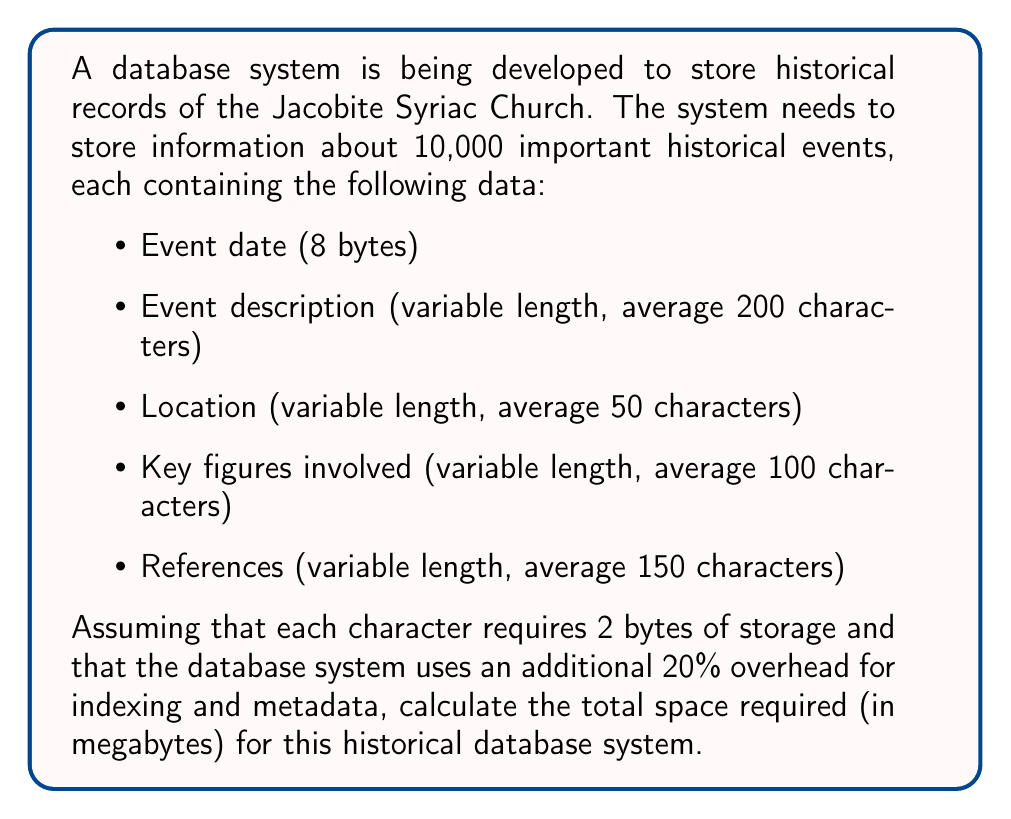Solve this math problem. Let's break down the problem and solve it step by step:

1. Calculate the space required for each field:
   - Event date: 8 bytes
   - Event description: $200 \times 2 = 400$ bytes
   - Location: $50 \times 2 = 100$ bytes
   - Key figures: $100 \times 2 = 200$ bytes
   - References: $150 \times 2 = 300$ bytes

2. Calculate the total space for one record:
   $$8 + 400 + 100 + 200 + 300 = 1008 \text{ bytes}$$

3. Calculate the total space for 10,000 records:
   $$10,000 \times 1008 = 10,080,000 \text{ bytes}$$

4. Add 20% overhead for indexing and metadata:
   $$10,080,000 \times 1.2 = 12,096,000 \text{ bytes}$$

5. Convert bytes to megabytes:
   $$\frac{12,096,000}{1,048,576} \approx 11.54 \text{ MB}$$

   Note: 1 MB = 1,048,576 bytes

Therefore, the total space required for the historical database system is approximately 11.54 MB.
Answer: 11.54 MB 